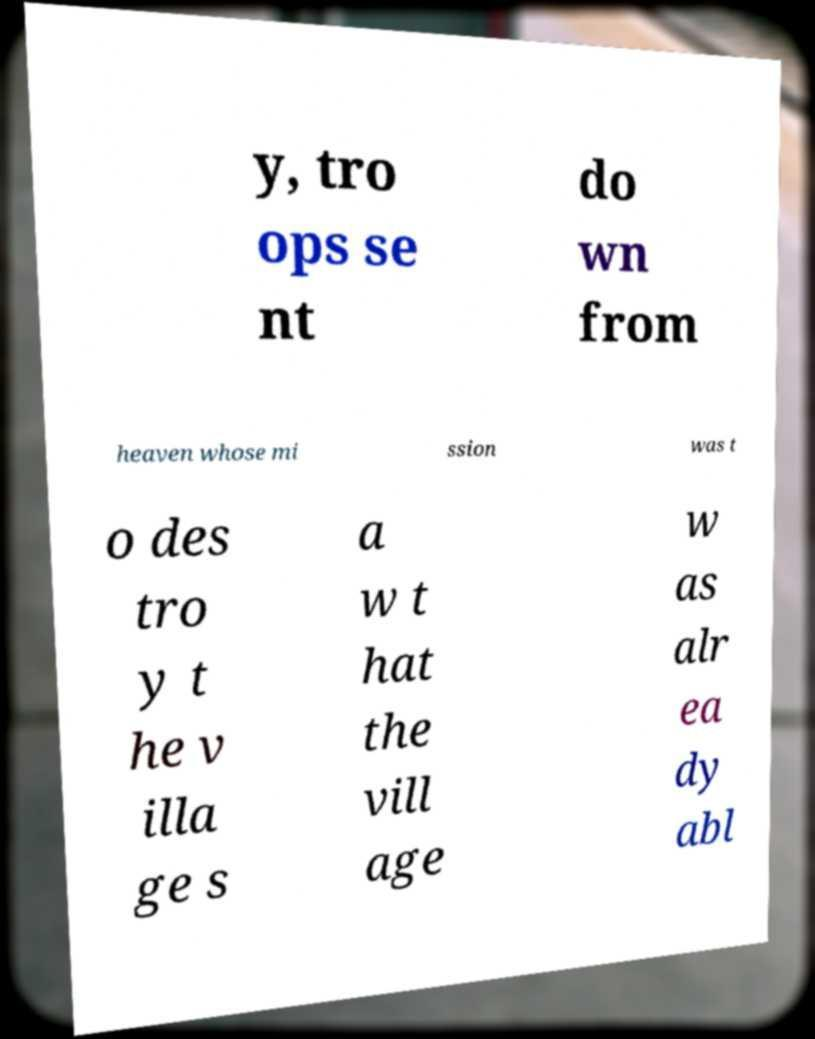Could you assist in decoding the text presented in this image and type it out clearly? y, tro ops se nt do wn from heaven whose mi ssion was t o des tro y t he v illa ge s a w t hat the vill age w as alr ea dy abl 